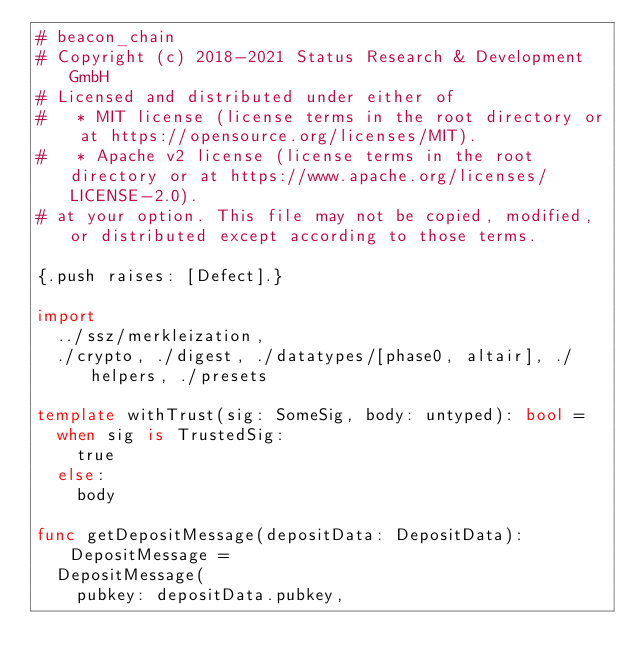Convert code to text. <code><loc_0><loc_0><loc_500><loc_500><_Nim_># beacon_chain
# Copyright (c) 2018-2021 Status Research & Development GmbH
# Licensed and distributed under either of
#   * MIT license (license terms in the root directory or at https://opensource.org/licenses/MIT).
#   * Apache v2 license (license terms in the root directory or at https://www.apache.org/licenses/LICENSE-2.0).
# at your option. This file may not be copied, modified, or distributed except according to those terms.

{.push raises: [Defect].}

import
  ../ssz/merkleization,
  ./crypto, ./digest, ./datatypes/[phase0, altair], ./helpers, ./presets

template withTrust(sig: SomeSig, body: untyped): bool =
  when sig is TrustedSig:
    true
  else:
    body

func getDepositMessage(depositData: DepositData): DepositMessage =
  DepositMessage(
    pubkey: depositData.pubkey,</code> 